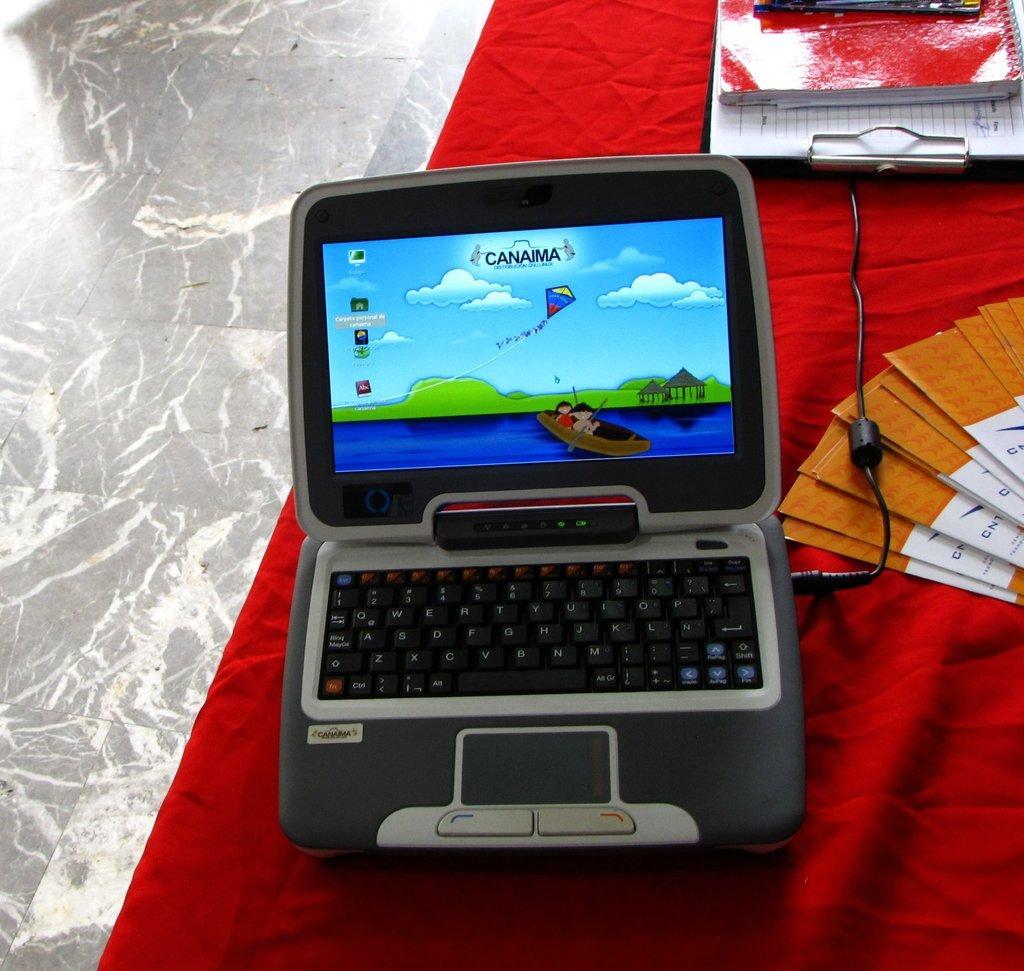How would you summarize this image in a sentence or two? Here we can see a toy laptop, cards, book, and a writing pad on a cloth. Here we can see floor. 